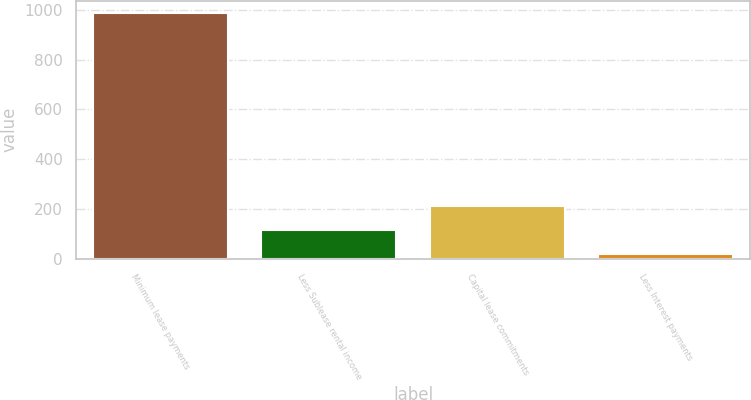<chart> <loc_0><loc_0><loc_500><loc_500><bar_chart><fcel>Minimum lease payments<fcel>Less Sublease rental income<fcel>Capital lease commitments<fcel>Less Interest payments<nl><fcel>988<fcel>115<fcel>212<fcel>18<nl></chart> 